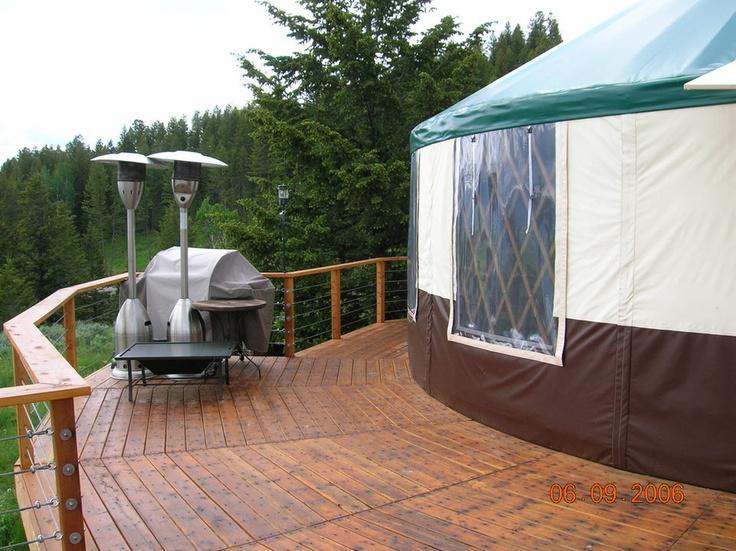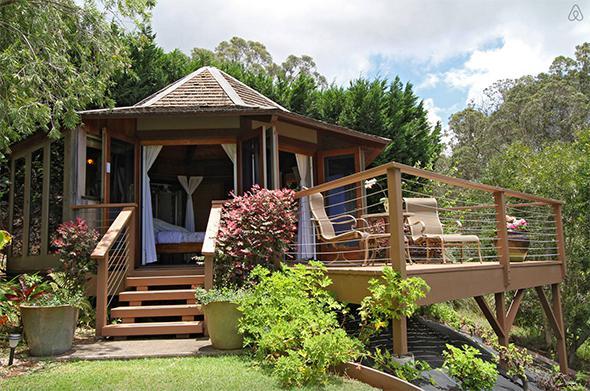The first image is the image on the left, the second image is the image on the right. Analyze the images presented: Is the assertion "There is a wooden rail around the hut in the image on the right." valid? Answer yes or no. Yes. The first image is the image on the left, the second image is the image on the right. Assess this claim about the two images: "Left image shows a domed structure with darker top and bottom sections and a wooden railed walkway curving around it.". Correct or not? Answer yes or no. Yes. 